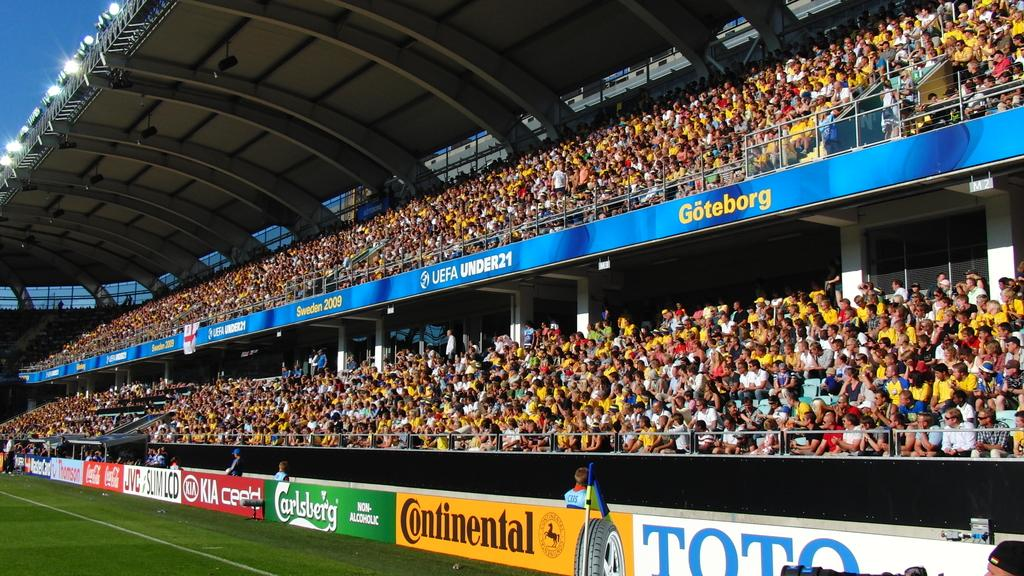<image>
Relay a brief, clear account of the picture shown. A sports stadium has ads for Continental and Goteborg around the edges. 